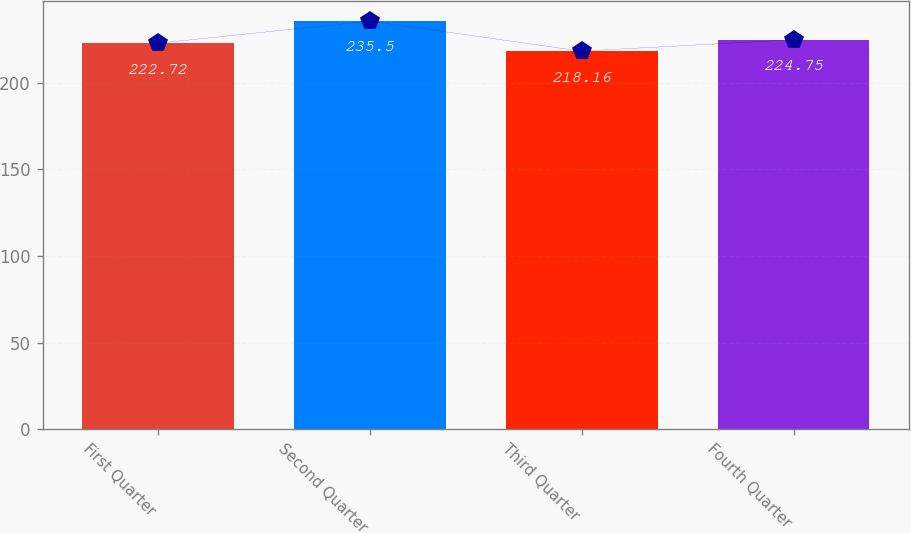<chart> <loc_0><loc_0><loc_500><loc_500><bar_chart><fcel>First Quarter<fcel>Second Quarter<fcel>Third Quarter<fcel>Fourth Quarter<nl><fcel>222.72<fcel>235.5<fcel>218.16<fcel>224.75<nl></chart> 